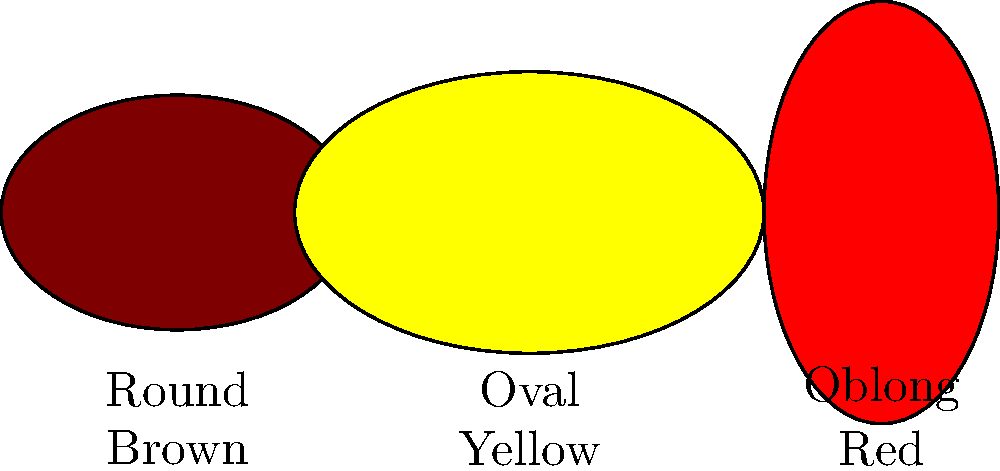Based on the image, which potato variety would be best suited for making traditional Irish boxty, considering its shape and starch content? To determine the best potato variety for making traditional Irish boxty, we need to consider the following steps:

1. Understand boxty: Boxty is a traditional Irish potato pancake that requires a mixture of grated raw potatoes and mashed cooked potatoes.

2. Analyze potato shapes:
   - Round: Compact and uniform, good for boiling and mashing
   - Oval: Versatile, suitable for various cooking methods
   - Oblong: Often low in moisture, high in starch

3. Consider starch content:
   - Higher starch content is preferable for boxty to achieve the right texture
   - Oblong potatoes typically have higher starch content

4. Evaluate color:
   - Brown potatoes are often associated with higher starch content
   - Yellow and red potatoes tend to be waxier and lower in starch

5. Choose the best option:
   The brown, oblong potato combines the ideal shape (high starch, low moisture) with the color typically associated with starchy potatoes.

Therefore, the brown, oblong potato would be the best choice for making traditional Irish boxty.
Answer: Brown, oblong potato 